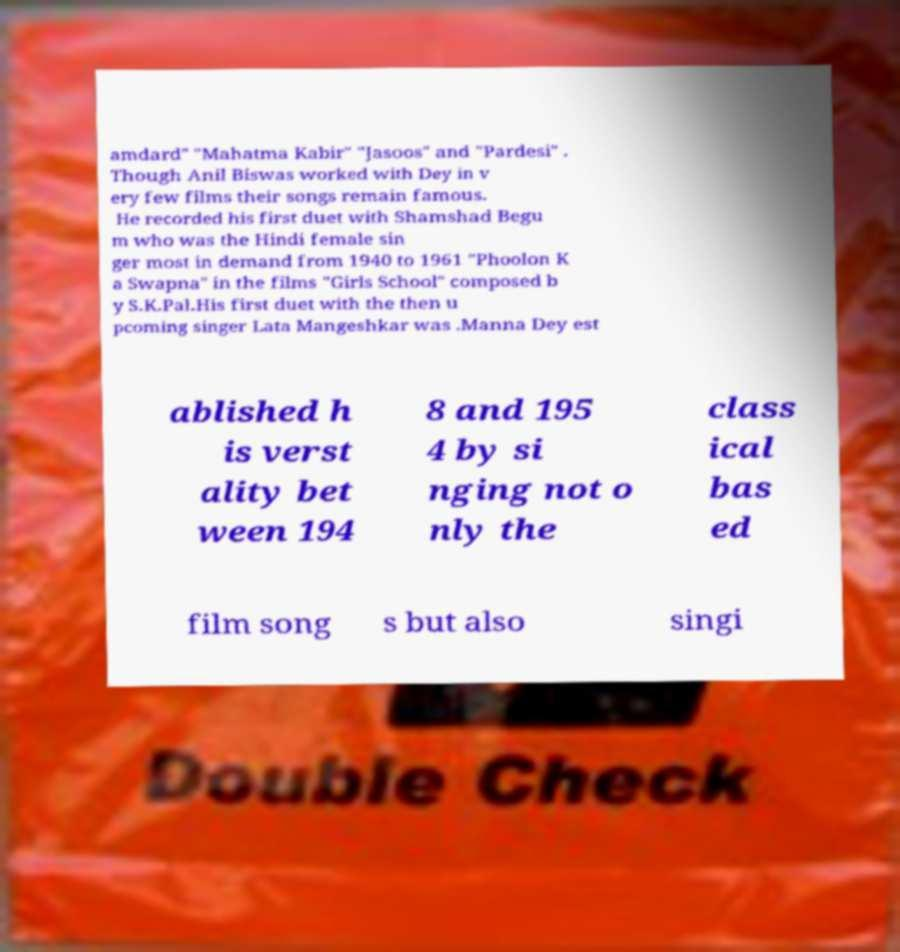Could you assist in decoding the text presented in this image and type it out clearly? amdard" "Mahatma Kabir" "Jasoos" and "Pardesi" . Though Anil Biswas worked with Dey in v ery few films their songs remain famous. He recorded his first duet with Shamshad Begu m who was the Hindi female sin ger most in demand from 1940 to 1961 "Phoolon K a Swapna" in the films "Girls School" composed b y S.K.Pal.His first duet with the then u pcoming singer Lata Mangeshkar was .Manna Dey est ablished h is verst ality bet ween 194 8 and 195 4 by si nging not o nly the class ical bas ed film song s but also singi 